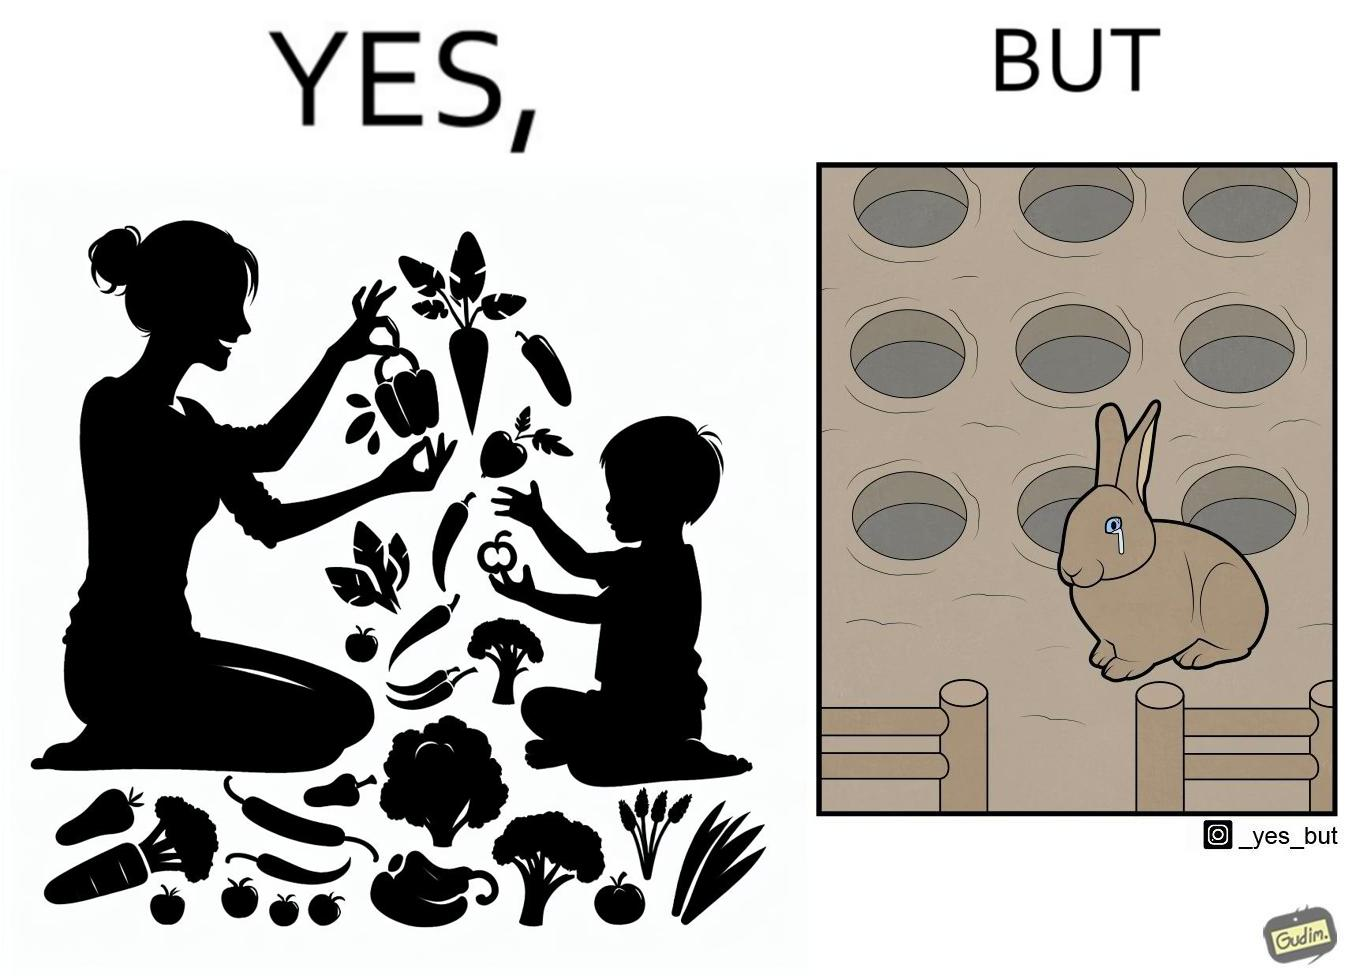Compare the left and right sides of this image. In the left part of the image: It is a woman and child making funny shapes with vegetables and playing with them In the right part of the image: It is rabbit crying in a ground full of holes 